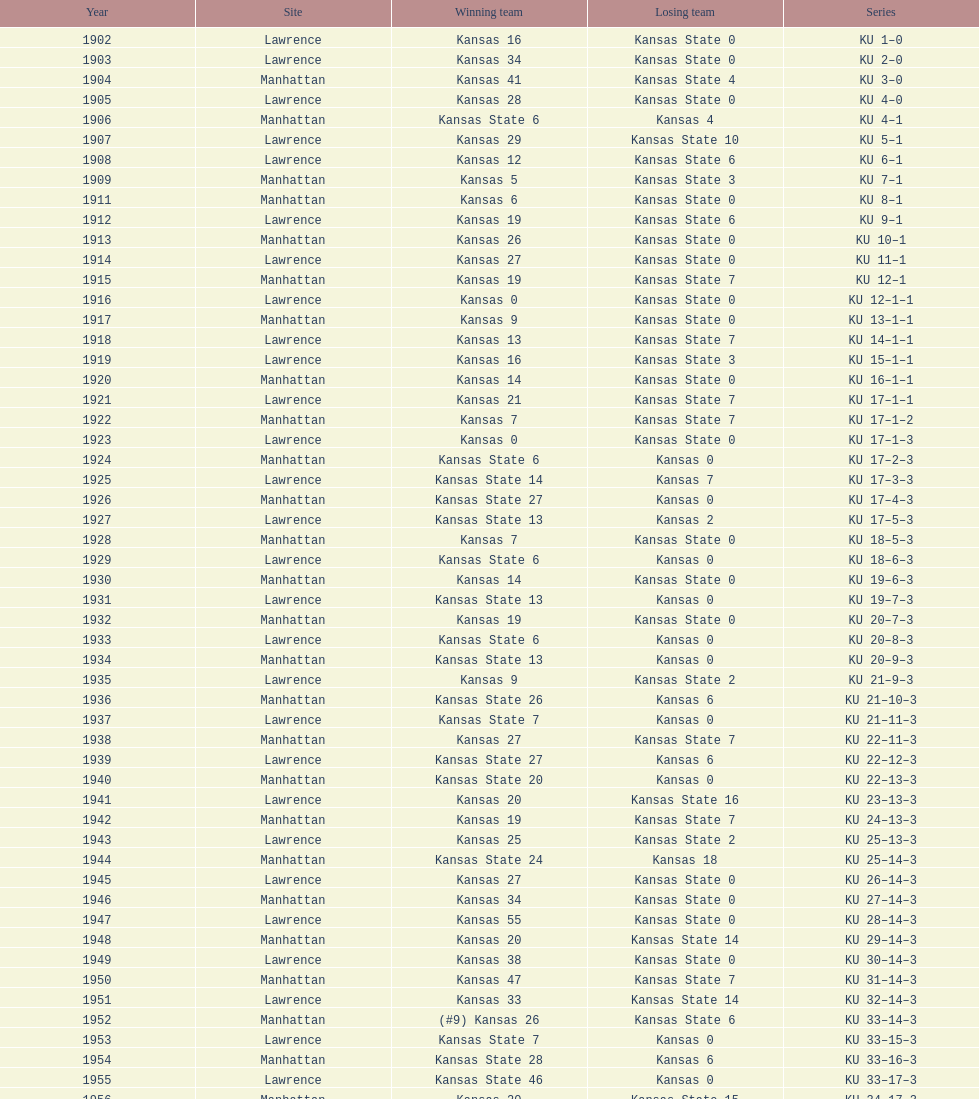What is the overall sum of games that have been played? 66. 